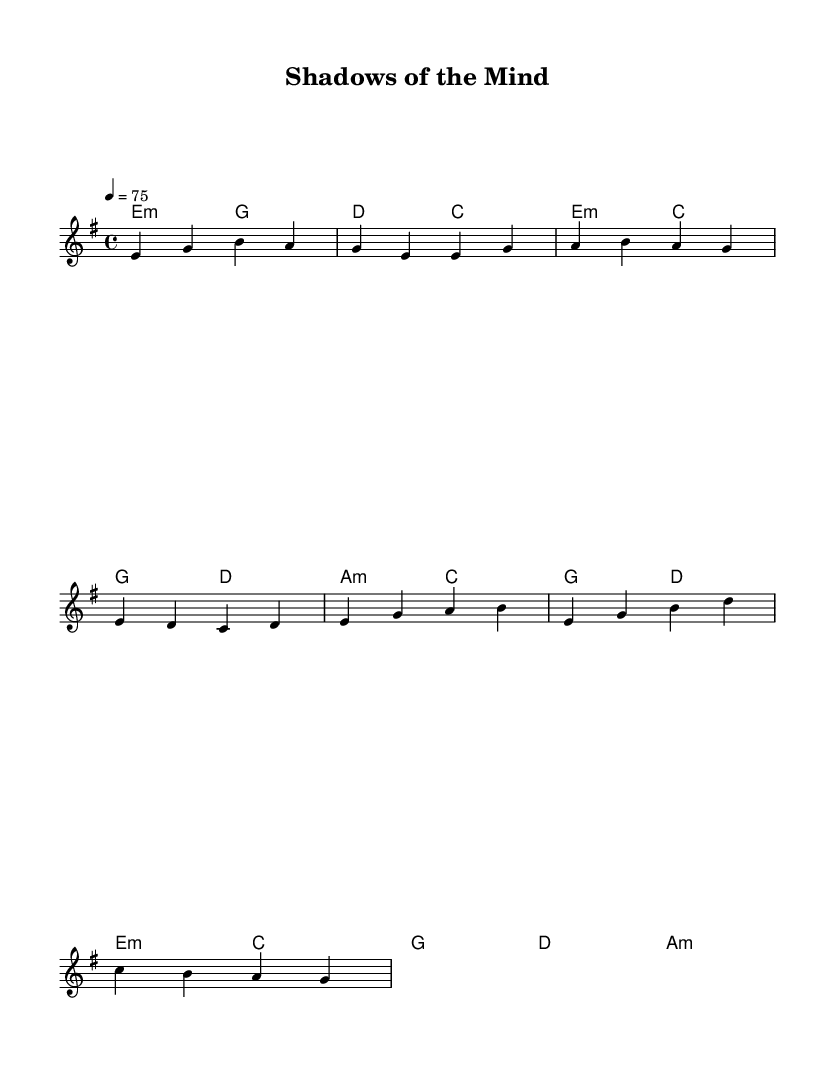What is the key signature of this music? The key signature is E minor, which has one sharp, F#. You can determine the key signature by looking at the clef and the sharps or flats indicated at the beginning of the staff.
Answer: E minor What is the time signature of this music? The time signature is 4/4, which means there are four beats per measure and the quarter note gets one beat. This can be seen in the time signature indicator at the beginning of the score.
Answer: 4/4 What is the tempo marking of this music? The tempo marking is 75 beats per minute. This is indicated by the "tempo" directive in the score, which tells the performer the speed of the piece.
Answer: 75 What are the first four notes of the melody? The first four notes of the melody are E, G, B, A. You can find this by examining the melody part and reading the notes in order from the beginning.
Answer: E, G, B, A What chord follows the pre-chorus section? The chord following the pre-chorus section is E minor. Analyzing the harmonies section, the progression includes a switch to E minor right after the pre-chorus ends.
Answer: E minor How many measures are in the chorus section? The chorus section contains four measures. By counting the measures from the beginning of the chorus notation to the end, you arrive at this total.
Answer: Four 